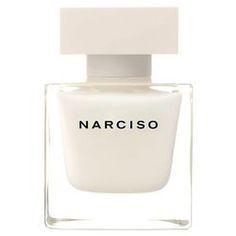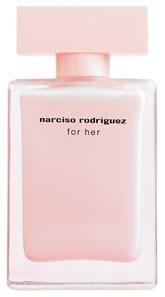The first image is the image on the left, the second image is the image on the right. Given the left and right images, does the statement "The image on the right contains both a bottle and a box." hold true? Answer yes or no. No. 